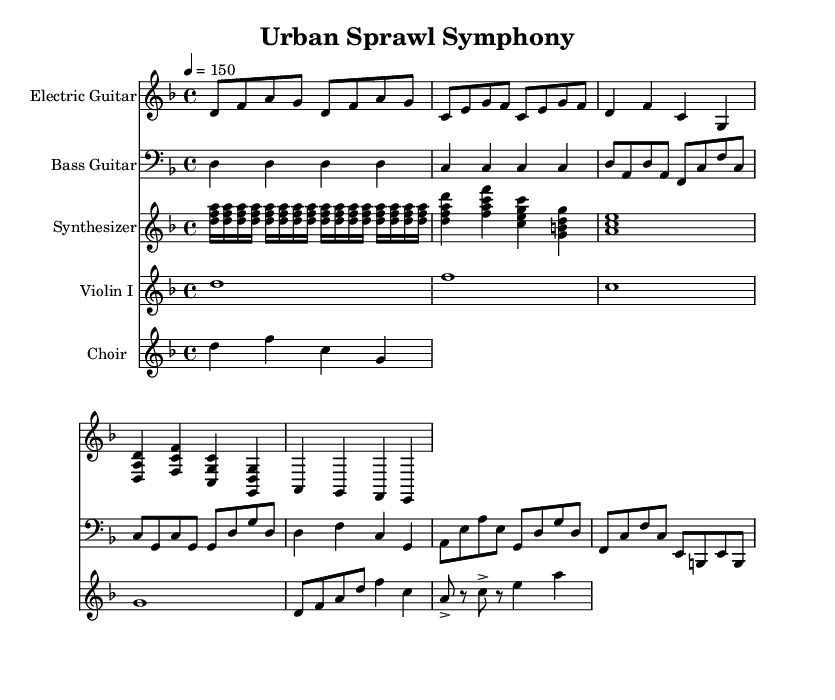What is the key signature of this music? The key signature is D minor, which has one flat (B flat).
Answer: D minor What is the time signature of this piece? The time signature is 4/4, indicating four beats per measure.
Answer: 4/4 What is the tempo marking given in the score? The tempo marking indicates a speed of 150 beats per minute, which is quite fast and common in metal music.
Answer: 150 How many measures does the main riff consist of? The main riff consists of 2 measures, as indicated by the notation under the electric guitar part.
Answer: 2 measures What is the texture of the choir in the chorus? The choir in the chorus sings lyrics, providing a vocal texture that contrasts with the instrumental parts.
Answer: Lyrics Which instruments are present in this score? The instruments listed are Electric Guitar, Bass Guitar, Synthesizer, Violin I, and Choir, highlighting the orchestral aspect of symphonic metal.
Answer: 5 instruments How does the music convey contrasts between urban and rural lifestyles? The contrasting dynamics and use of orchestral versus aggressive metal instrumentation represent the differences between the chaotic urban environment and the calm rural setting.
Answer: Dynamics and instrumentation 